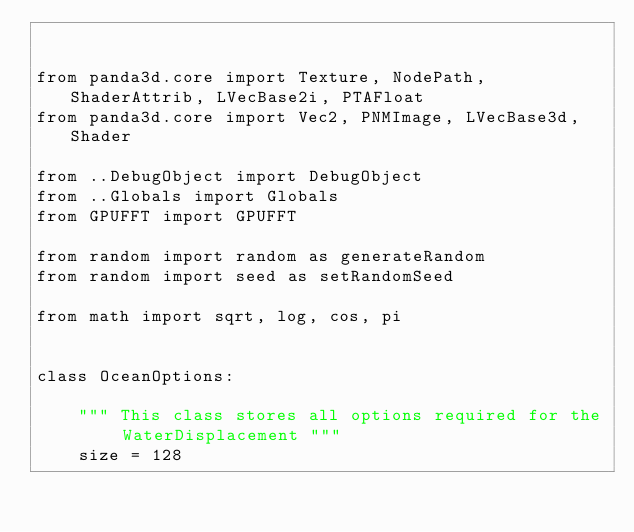Convert code to text. <code><loc_0><loc_0><loc_500><loc_500><_Python_>

from panda3d.core import Texture, NodePath, ShaderAttrib, LVecBase2i, PTAFloat
from panda3d.core import Vec2, PNMImage, LVecBase3d, Shader

from ..DebugObject import DebugObject
from ..Globals import Globals
from GPUFFT import GPUFFT

from random import random as generateRandom
from random import seed as setRandomSeed

from math import sqrt, log, cos, pi


class OceanOptions:

    """ This class stores all options required for the WaterDisplacement """
    size = 128
</code> 